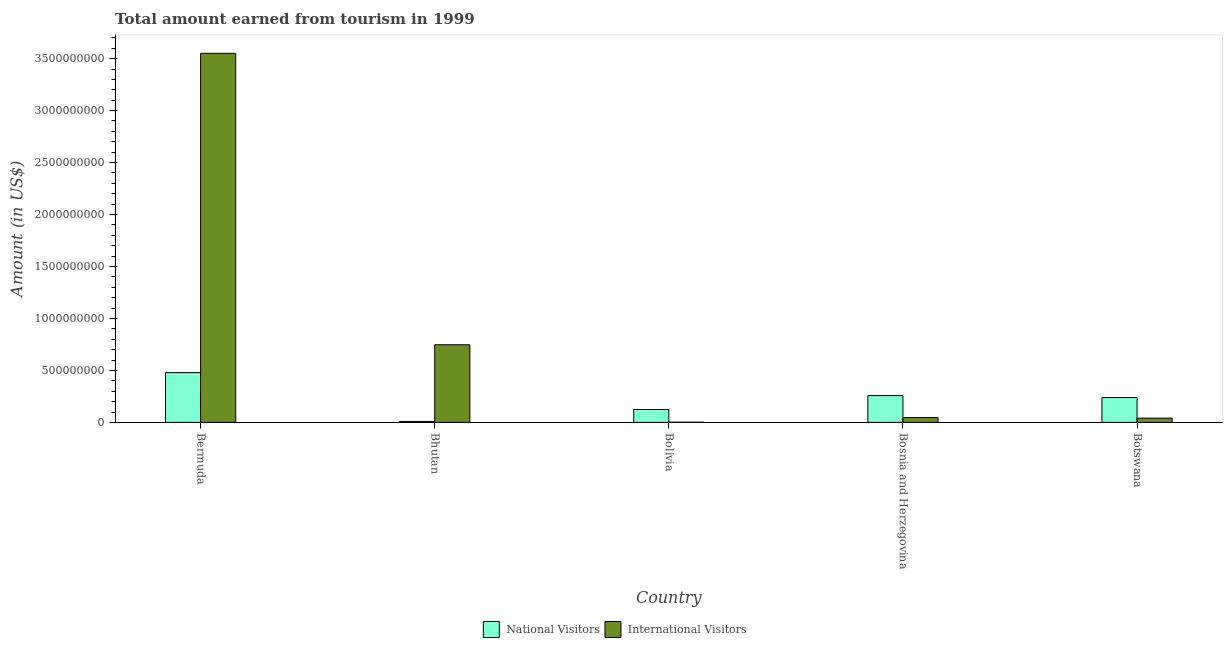How many bars are there on the 4th tick from the left?
Make the answer very short. 2. How many bars are there on the 5th tick from the right?
Keep it short and to the point. 2. What is the label of the 1st group of bars from the left?
Ensure brevity in your answer.  Bermuda. In how many cases, is the number of bars for a given country not equal to the number of legend labels?
Give a very brief answer. 0. What is the amount earned from international visitors in Bosnia and Herzegovina?
Your response must be concise. 4.70e+07. Across all countries, what is the maximum amount earned from international visitors?
Your answer should be compact. 3.55e+09. Across all countries, what is the minimum amount earned from national visitors?
Keep it short and to the point. 9.00e+06. In which country was the amount earned from national visitors maximum?
Your response must be concise. Bermuda. In which country was the amount earned from international visitors minimum?
Provide a succinct answer. Bolivia. What is the total amount earned from national visitors in the graph?
Give a very brief answer. 1.11e+09. What is the difference between the amount earned from national visitors in Bolivia and that in Botswana?
Give a very brief answer. -1.15e+08. What is the difference between the amount earned from international visitors in Bolivia and the amount earned from national visitors in Botswana?
Provide a short and direct response. -2.37e+08. What is the average amount earned from national visitors per country?
Provide a short and direct response. 2.22e+08. What is the difference between the amount earned from international visitors and amount earned from national visitors in Bolivia?
Your answer should be compact. -1.22e+08. What is the ratio of the amount earned from international visitors in Bhutan to that in Botswana?
Keep it short and to the point. 18.22. What is the difference between the highest and the second highest amount earned from national visitors?
Keep it short and to the point. 2.21e+08. What is the difference between the highest and the lowest amount earned from national visitors?
Your answer should be compact. 4.70e+08. In how many countries, is the amount earned from international visitors greater than the average amount earned from international visitors taken over all countries?
Your answer should be very brief. 1. What does the 2nd bar from the left in Bosnia and Herzegovina represents?
Make the answer very short. International Visitors. What does the 1st bar from the right in Botswana represents?
Provide a succinct answer. International Visitors. Are all the bars in the graph horizontal?
Ensure brevity in your answer.  No. How many countries are there in the graph?
Offer a terse response. 5. What is the difference between two consecutive major ticks on the Y-axis?
Give a very brief answer. 5.00e+08. Are the values on the major ticks of Y-axis written in scientific E-notation?
Give a very brief answer. No. Does the graph contain any zero values?
Provide a succinct answer. No. Does the graph contain grids?
Make the answer very short. No. Where does the legend appear in the graph?
Provide a short and direct response. Bottom center. What is the title of the graph?
Provide a succinct answer. Total amount earned from tourism in 1999. Does "Age 65(female)" appear as one of the legend labels in the graph?
Provide a succinct answer. No. What is the label or title of the Y-axis?
Your answer should be very brief. Amount (in US$). What is the Amount (in US$) of National Visitors in Bermuda?
Your answer should be compact. 4.79e+08. What is the Amount (in US$) of International Visitors in Bermuda?
Provide a short and direct response. 3.55e+09. What is the Amount (in US$) of National Visitors in Bhutan?
Provide a short and direct response. 9.00e+06. What is the Amount (in US$) of International Visitors in Bhutan?
Offer a very short reply. 7.47e+08. What is the Amount (in US$) in National Visitors in Bolivia?
Offer a terse response. 1.24e+08. What is the Amount (in US$) in International Visitors in Bolivia?
Keep it short and to the point. 2.00e+06. What is the Amount (in US$) in National Visitors in Bosnia and Herzegovina?
Provide a succinct answer. 2.58e+08. What is the Amount (in US$) of International Visitors in Bosnia and Herzegovina?
Your answer should be very brief. 4.70e+07. What is the Amount (in US$) of National Visitors in Botswana?
Offer a terse response. 2.39e+08. What is the Amount (in US$) of International Visitors in Botswana?
Your answer should be compact. 4.10e+07. Across all countries, what is the maximum Amount (in US$) in National Visitors?
Your response must be concise. 4.79e+08. Across all countries, what is the maximum Amount (in US$) in International Visitors?
Give a very brief answer. 3.55e+09. Across all countries, what is the minimum Amount (in US$) in National Visitors?
Offer a terse response. 9.00e+06. Across all countries, what is the minimum Amount (in US$) of International Visitors?
Provide a short and direct response. 2.00e+06. What is the total Amount (in US$) in National Visitors in the graph?
Offer a very short reply. 1.11e+09. What is the total Amount (in US$) of International Visitors in the graph?
Offer a terse response. 4.39e+09. What is the difference between the Amount (in US$) in National Visitors in Bermuda and that in Bhutan?
Your answer should be compact. 4.70e+08. What is the difference between the Amount (in US$) of International Visitors in Bermuda and that in Bhutan?
Make the answer very short. 2.80e+09. What is the difference between the Amount (in US$) of National Visitors in Bermuda and that in Bolivia?
Give a very brief answer. 3.55e+08. What is the difference between the Amount (in US$) in International Visitors in Bermuda and that in Bolivia?
Your response must be concise. 3.55e+09. What is the difference between the Amount (in US$) of National Visitors in Bermuda and that in Bosnia and Herzegovina?
Ensure brevity in your answer.  2.21e+08. What is the difference between the Amount (in US$) of International Visitors in Bermuda and that in Bosnia and Herzegovina?
Offer a terse response. 3.50e+09. What is the difference between the Amount (in US$) of National Visitors in Bermuda and that in Botswana?
Offer a terse response. 2.40e+08. What is the difference between the Amount (in US$) of International Visitors in Bermuda and that in Botswana?
Offer a terse response. 3.51e+09. What is the difference between the Amount (in US$) of National Visitors in Bhutan and that in Bolivia?
Give a very brief answer. -1.15e+08. What is the difference between the Amount (in US$) in International Visitors in Bhutan and that in Bolivia?
Offer a very short reply. 7.45e+08. What is the difference between the Amount (in US$) in National Visitors in Bhutan and that in Bosnia and Herzegovina?
Offer a terse response. -2.49e+08. What is the difference between the Amount (in US$) of International Visitors in Bhutan and that in Bosnia and Herzegovina?
Keep it short and to the point. 7.00e+08. What is the difference between the Amount (in US$) of National Visitors in Bhutan and that in Botswana?
Make the answer very short. -2.30e+08. What is the difference between the Amount (in US$) in International Visitors in Bhutan and that in Botswana?
Your answer should be compact. 7.06e+08. What is the difference between the Amount (in US$) in National Visitors in Bolivia and that in Bosnia and Herzegovina?
Your response must be concise. -1.34e+08. What is the difference between the Amount (in US$) in International Visitors in Bolivia and that in Bosnia and Herzegovina?
Keep it short and to the point. -4.50e+07. What is the difference between the Amount (in US$) in National Visitors in Bolivia and that in Botswana?
Offer a terse response. -1.15e+08. What is the difference between the Amount (in US$) of International Visitors in Bolivia and that in Botswana?
Provide a succinct answer. -3.90e+07. What is the difference between the Amount (in US$) in National Visitors in Bosnia and Herzegovina and that in Botswana?
Make the answer very short. 1.90e+07. What is the difference between the Amount (in US$) in National Visitors in Bermuda and the Amount (in US$) in International Visitors in Bhutan?
Make the answer very short. -2.68e+08. What is the difference between the Amount (in US$) of National Visitors in Bermuda and the Amount (in US$) of International Visitors in Bolivia?
Offer a very short reply. 4.77e+08. What is the difference between the Amount (in US$) in National Visitors in Bermuda and the Amount (in US$) in International Visitors in Bosnia and Herzegovina?
Offer a very short reply. 4.32e+08. What is the difference between the Amount (in US$) of National Visitors in Bermuda and the Amount (in US$) of International Visitors in Botswana?
Provide a short and direct response. 4.38e+08. What is the difference between the Amount (in US$) of National Visitors in Bhutan and the Amount (in US$) of International Visitors in Bosnia and Herzegovina?
Provide a short and direct response. -3.80e+07. What is the difference between the Amount (in US$) of National Visitors in Bhutan and the Amount (in US$) of International Visitors in Botswana?
Give a very brief answer. -3.20e+07. What is the difference between the Amount (in US$) of National Visitors in Bolivia and the Amount (in US$) of International Visitors in Bosnia and Herzegovina?
Provide a short and direct response. 7.70e+07. What is the difference between the Amount (in US$) of National Visitors in Bolivia and the Amount (in US$) of International Visitors in Botswana?
Provide a succinct answer. 8.30e+07. What is the difference between the Amount (in US$) in National Visitors in Bosnia and Herzegovina and the Amount (in US$) in International Visitors in Botswana?
Offer a terse response. 2.17e+08. What is the average Amount (in US$) in National Visitors per country?
Offer a terse response. 2.22e+08. What is the average Amount (in US$) of International Visitors per country?
Ensure brevity in your answer.  8.78e+08. What is the difference between the Amount (in US$) of National Visitors and Amount (in US$) of International Visitors in Bermuda?
Offer a very short reply. -3.07e+09. What is the difference between the Amount (in US$) in National Visitors and Amount (in US$) in International Visitors in Bhutan?
Give a very brief answer. -7.38e+08. What is the difference between the Amount (in US$) of National Visitors and Amount (in US$) of International Visitors in Bolivia?
Your answer should be compact. 1.22e+08. What is the difference between the Amount (in US$) in National Visitors and Amount (in US$) in International Visitors in Bosnia and Herzegovina?
Your answer should be very brief. 2.11e+08. What is the difference between the Amount (in US$) of National Visitors and Amount (in US$) of International Visitors in Botswana?
Provide a succinct answer. 1.98e+08. What is the ratio of the Amount (in US$) of National Visitors in Bermuda to that in Bhutan?
Give a very brief answer. 53.22. What is the ratio of the Amount (in US$) of International Visitors in Bermuda to that in Bhutan?
Your answer should be very brief. 4.75. What is the ratio of the Amount (in US$) in National Visitors in Bermuda to that in Bolivia?
Give a very brief answer. 3.86. What is the ratio of the Amount (in US$) in International Visitors in Bermuda to that in Bolivia?
Your response must be concise. 1775.5. What is the ratio of the Amount (in US$) of National Visitors in Bermuda to that in Bosnia and Herzegovina?
Keep it short and to the point. 1.86. What is the ratio of the Amount (in US$) of International Visitors in Bermuda to that in Bosnia and Herzegovina?
Make the answer very short. 75.55. What is the ratio of the Amount (in US$) of National Visitors in Bermuda to that in Botswana?
Your answer should be compact. 2. What is the ratio of the Amount (in US$) in International Visitors in Bermuda to that in Botswana?
Provide a short and direct response. 86.61. What is the ratio of the Amount (in US$) of National Visitors in Bhutan to that in Bolivia?
Make the answer very short. 0.07. What is the ratio of the Amount (in US$) in International Visitors in Bhutan to that in Bolivia?
Make the answer very short. 373.5. What is the ratio of the Amount (in US$) in National Visitors in Bhutan to that in Bosnia and Herzegovina?
Give a very brief answer. 0.03. What is the ratio of the Amount (in US$) in International Visitors in Bhutan to that in Bosnia and Herzegovina?
Make the answer very short. 15.89. What is the ratio of the Amount (in US$) of National Visitors in Bhutan to that in Botswana?
Your answer should be compact. 0.04. What is the ratio of the Amount (in US$) of International Visitors in Bhutan to that in Botswana?
Your response must be concise. 18.22. What is the ratio of the Amount (in US$) in National Visitors in Bolivia to that in Bosnia and Herzegovina?
Offer a very short reply. 0.48. What is the ratio of the Amount (in US$) in International Visitors in Bolivia to that in Bosnia and Herzegovina?
Offer a terse response. 0.04. What is the ratio of the Amount (in US$) in National Visitors in Bolivia to that in Botswana?
Ensure brevity in your answer.  0.52. What is the ratio of the Amount (in US$) of International Visitors in Bolivia to that in Botswana?
Your response must be concise. 0.05. What is the ratio of the Amount (in US$) of National Visitors in Bosnia and Herzegovina to that in Botswana?
Offer a terse response. 1.08. What is the ratio of the Amount (in US$) in International Visitors in Bosnia and Herzegovina to that in Botswana?
Offer a very short reply. 1.15. What is the difference between the highest and the second highest Amount (in US$) of National Visitors?
Offer a very short reply. 2.21e+08. What is the difference between the highest and the second highest Amount (in US$) of International Visitors?
Your answer should be compact. 2.80e+09. What is the difference between the highest and the lowest Amount (in US$) of National Visitors?
Make the answer very short. 4.70e+08. What is the difference between the highest and the lowest Amount (in US$) in International Visitors?
Give a very brief answer. 3.55e+09. 